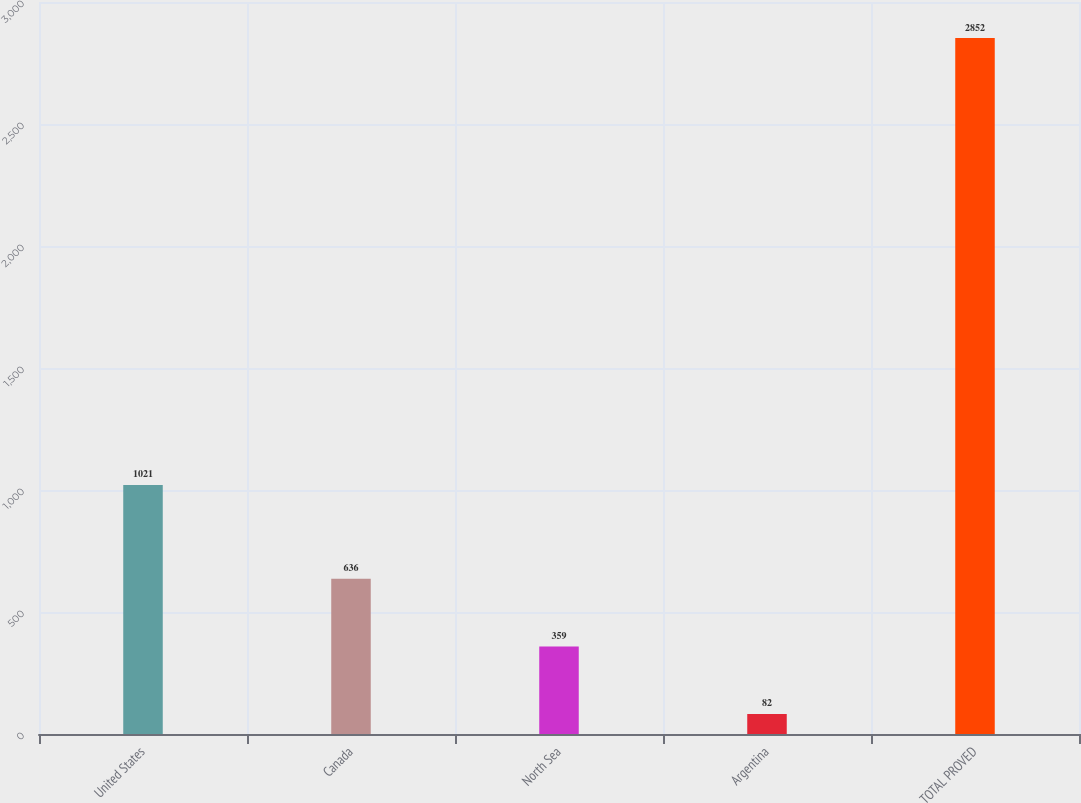<chart> <loc_0><loc_0><loc_500><loc_500><bar_chart><fcel>United States<fcel>Canada<fcel>North Sea<fcel>Argentina<fcel>TOTAL PROVED<nl><fcel>1021<fcel>636<fcel>359<fcel>82<fcel>2852<nl></chart> 